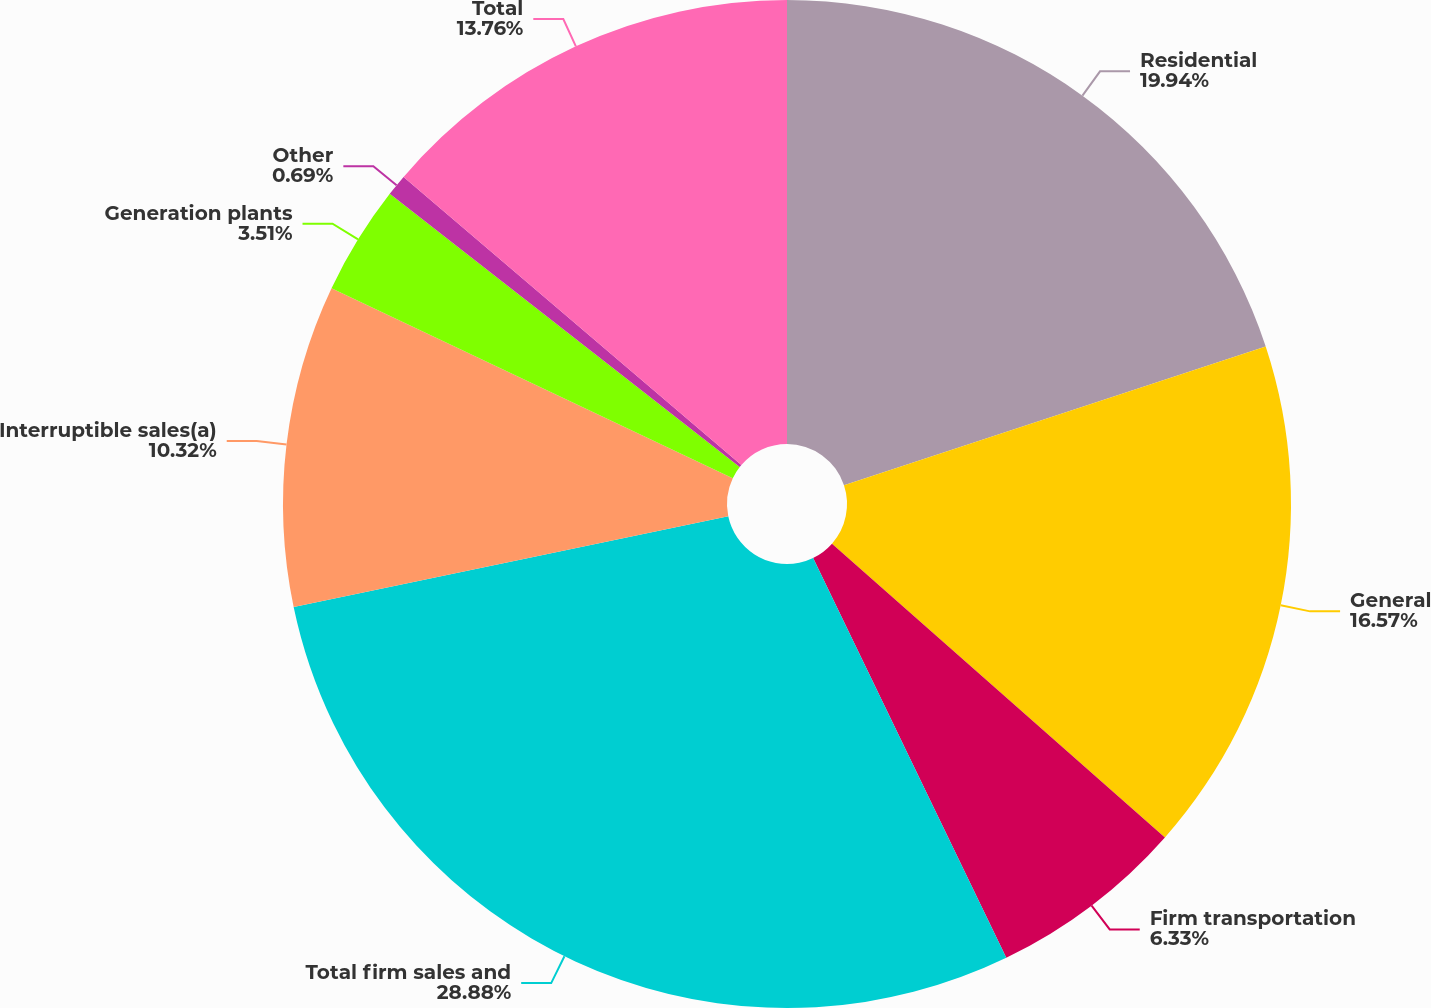Convert chart. <chart><loc_0><loc_0><loc_500><loc_500><pie_chart><fcel>Residential<fcel>General<fcel>Firm transportation<fcel>Total firm sales and<fcel>Interruptible sales(a)<fcel>Generation plants<fcel>Other<fcel>Total<nl><fcel>19.94%<fcel>16.57%<fcel>6.33%<fcel>28.89%<fcel>10.32%<fcel>3.51%<fcel>0.69%<fcel>13.76%<nl></chart> 